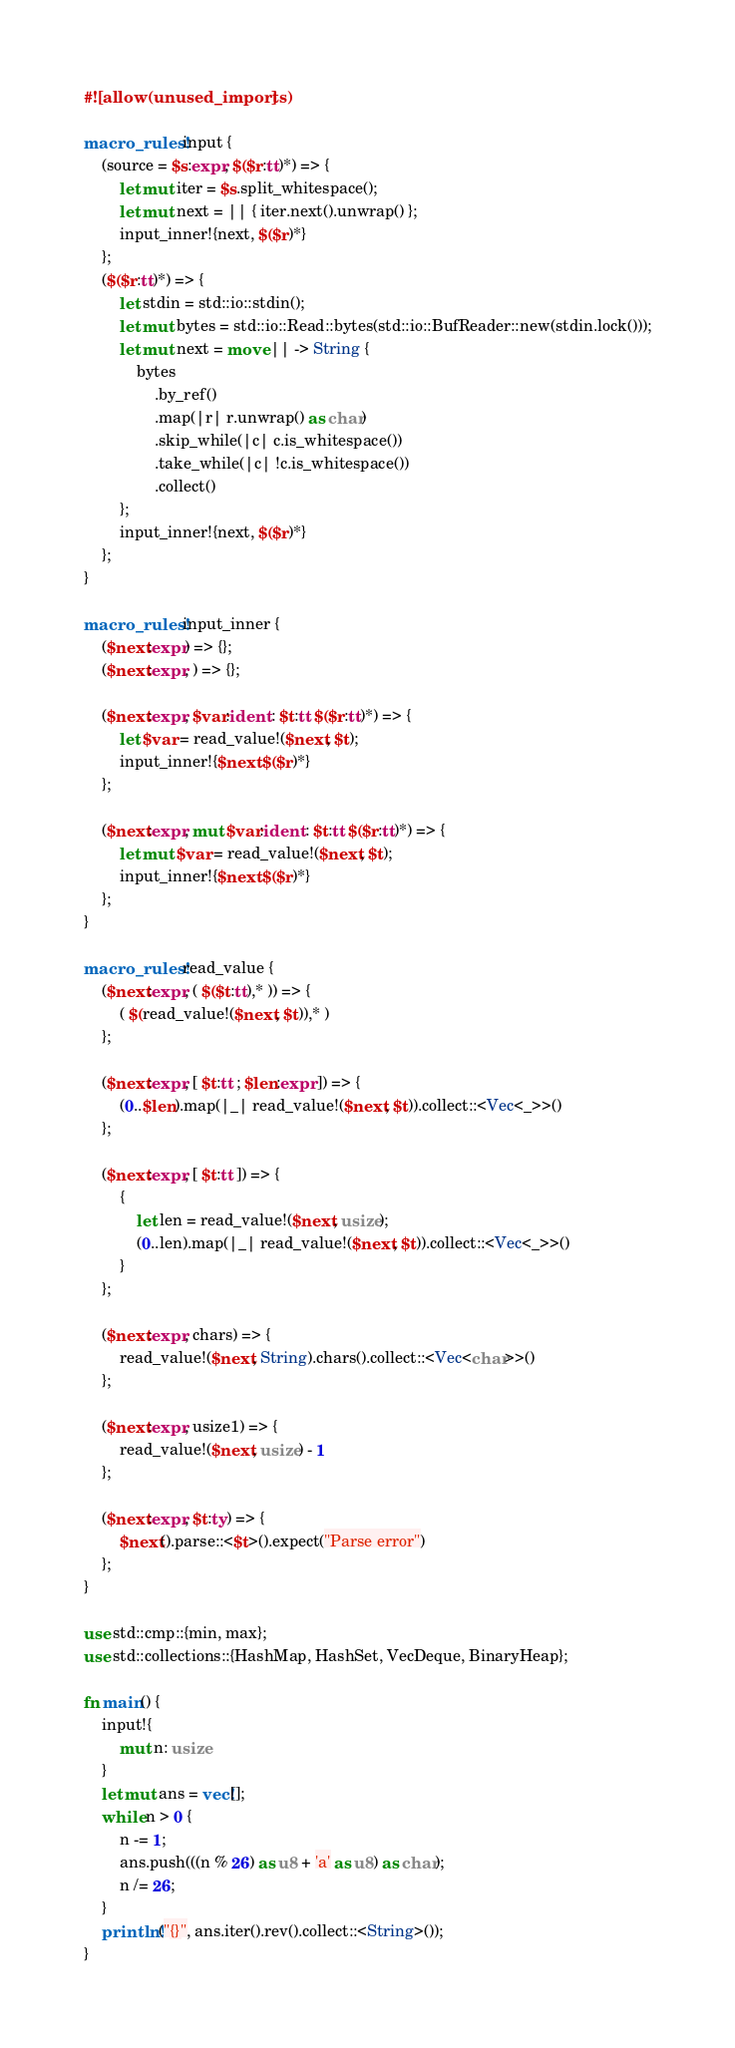Convert code to text. <code><loc_0><loc_0><loc_500><loc_500><_Rust_>#![allow(unused_imports)]

macro_rules! input {
    (source = $s:expr, $($r:tt)*) => {
        let mut iter = $s.split_whitespace();
        let mut next = || { iter.next().unwrap() };
        input_inner!{next, $($r)*}
    };
    ($($r:tt)*) => {
        let stdin = std::io::stdin();
        let mut bytes = std::io::Read::bytes(std::io::BufReader::new(stdin.lock()));
        let mut next = move || -> String {
            bytes
                .by_ref()
                .map(|r| r.unwrap() as char)
                .skip_while(|c| c.is_whitespace())
                .take_while(|c| !c.is_whitespace())
                .collect()
        };
        input_inner!{next, $($r)*}
    };
}

macro_rules! input_inner {
    ($next:expr) => {};
    ($next:expr, ) => {};

    ($next:expr, $var:ident : $t:tt $($r:tt)*) => {
        let $var = read_value!($next, $t);
        input_inner!{$next $($r)*}
    };

    ($next:expr, mut $var:ident : $t:tt $($r:tt)*) => {
        let mut $var = read_value!($next, $t);
        input_inner!{$next $($r)*}
    };
}

macro_rules! read_value {
    ($next:expr, ( $($t:tt),* )) => {
        ( $(read_value!($next, $t)),* )
    };

    ($next:expr, [ $t:tt ; $len:expr ]) => {
        (0..$len).map(|_| read_value!($next, $t)).collect::<Vec<_>>()
    };

    ($next:expr, [ $t:tt ]) => {
        {
            let len = read_value!($next, usize);
            (0..len).map(|_| read_value!($next, $t)).collect::<Vec<_>>()
        }
    };

    ($next:expr, chars) => {
        read_value!($next, String).chars().collect::<Vec<char>>()
    };

    ($next:expr, usize1) => {
        read_value!($next, usize) - 1
    };

    ($next:expr, $t:ty) => {
        $next().parse::<$t>().expect("Parse error")
    };
}

use std::cmp::{min, max};
use std::collections::{HashMap, HashSet, VecDeque, BinaryHeap};

fn main() {
    input!{
        mut n: usize
    }
    let mut ans = vec![];
    while n > 0 {
        n -= 1;
        ans.push(((n % 26) as u8 + 'a' as u8) as char);
        n /= 26;
    }
    println!("{}", ans.iter().rev().collect::<String>());
}
</code> 